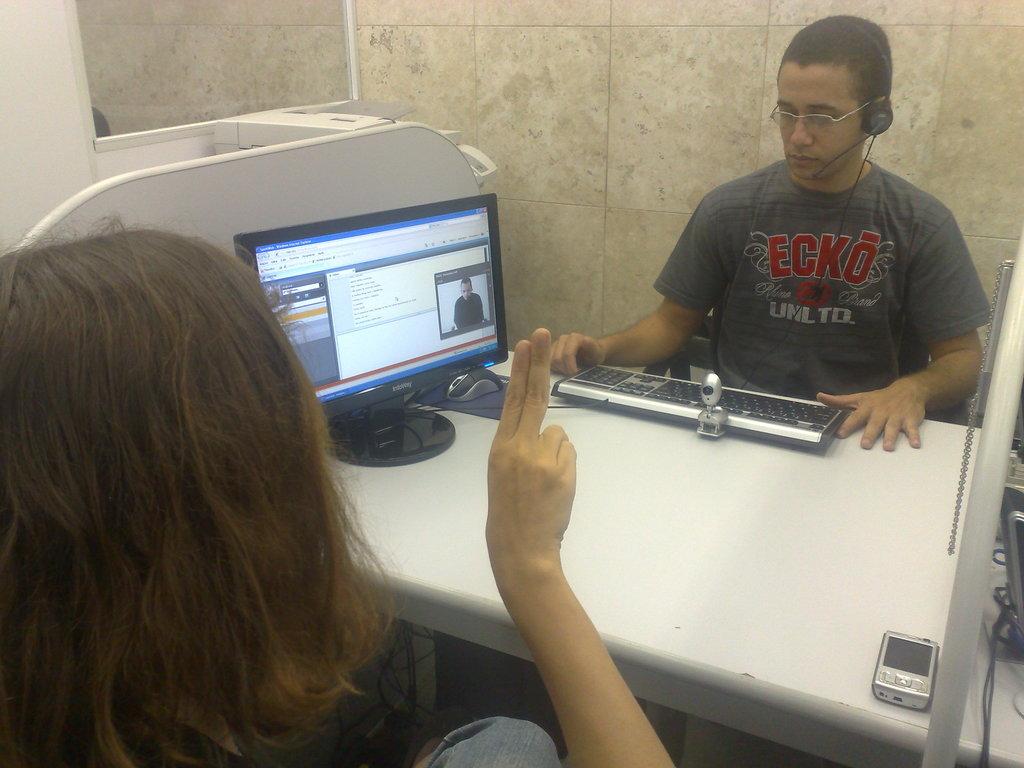What name is on the guy's t-shirt?
Your answer should be compact. Ecko. What is written in white under the brand name?
Offer a very short reply. Unltd. 